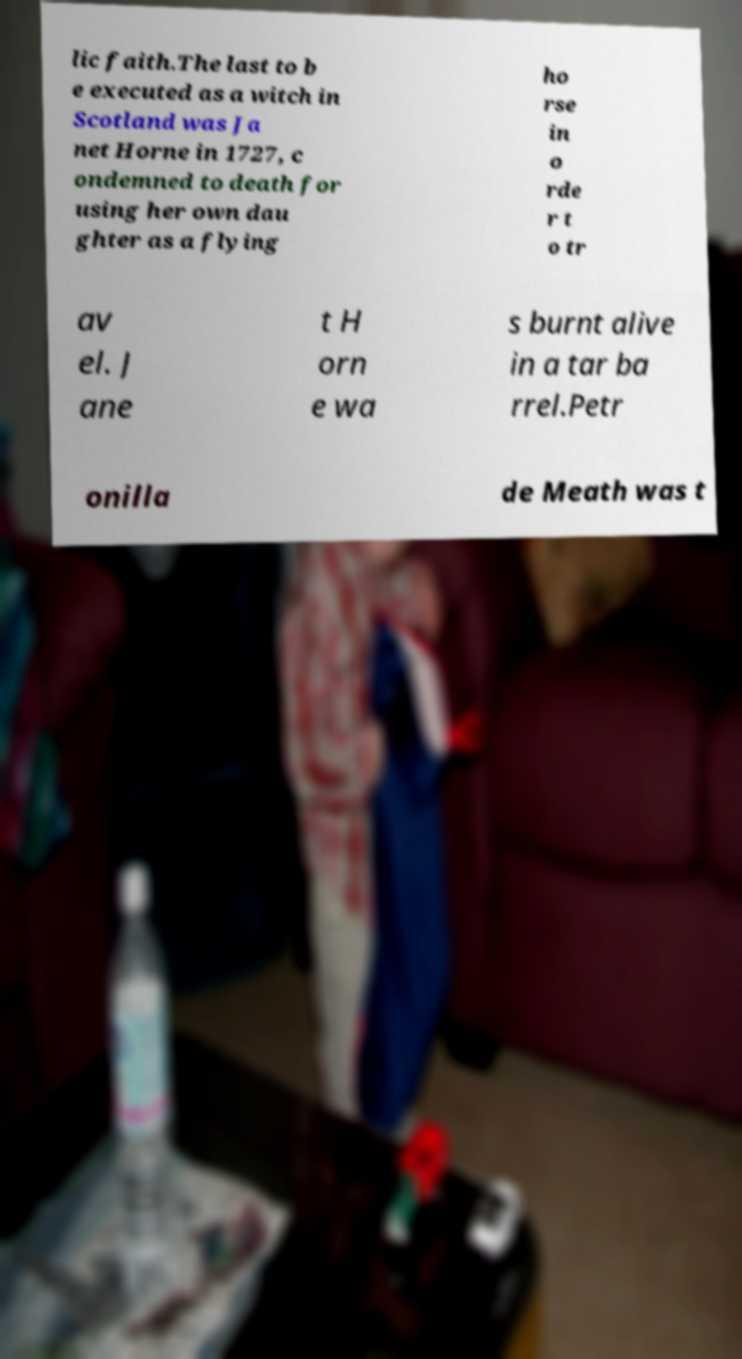I need the written content from this picture converted into text. Can you do that? lic faith.The last to b e executed as a witch in Scotland was Ja net Horne in 1727, c ondemned to death for using her own dau ghter as a flying ho rse in o rde r t o tr av el. J ane t H orn e wa s burnt alive in a tar ba rrel.Petr onilla de Meath was t 